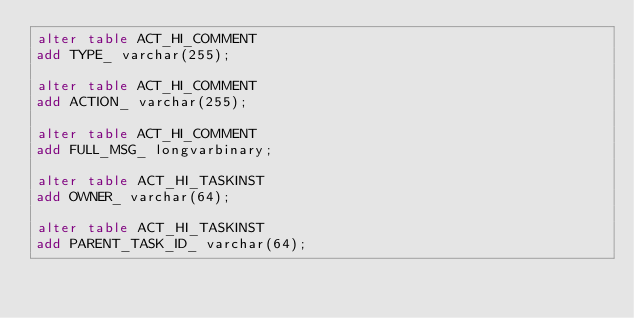<code> <loc_0><loc_0><loc_500><loc_500><_SQL_>alter table ACT_HI_COMMENT 
add TYPE_ varchar(255);

alter table ACT_HI_COMMENT 
add ACTION_ varchar(255);

alter table ACT_HI_COMMENT 
add FULL_MSG_ longvarbinary;

alter table ACT_HI_TASKINST 
add OWNER_ varchar(64);

alter table ACT_HI_TASKINST 
add PARENT_TASK_ID_ varchar(64);
</code> 